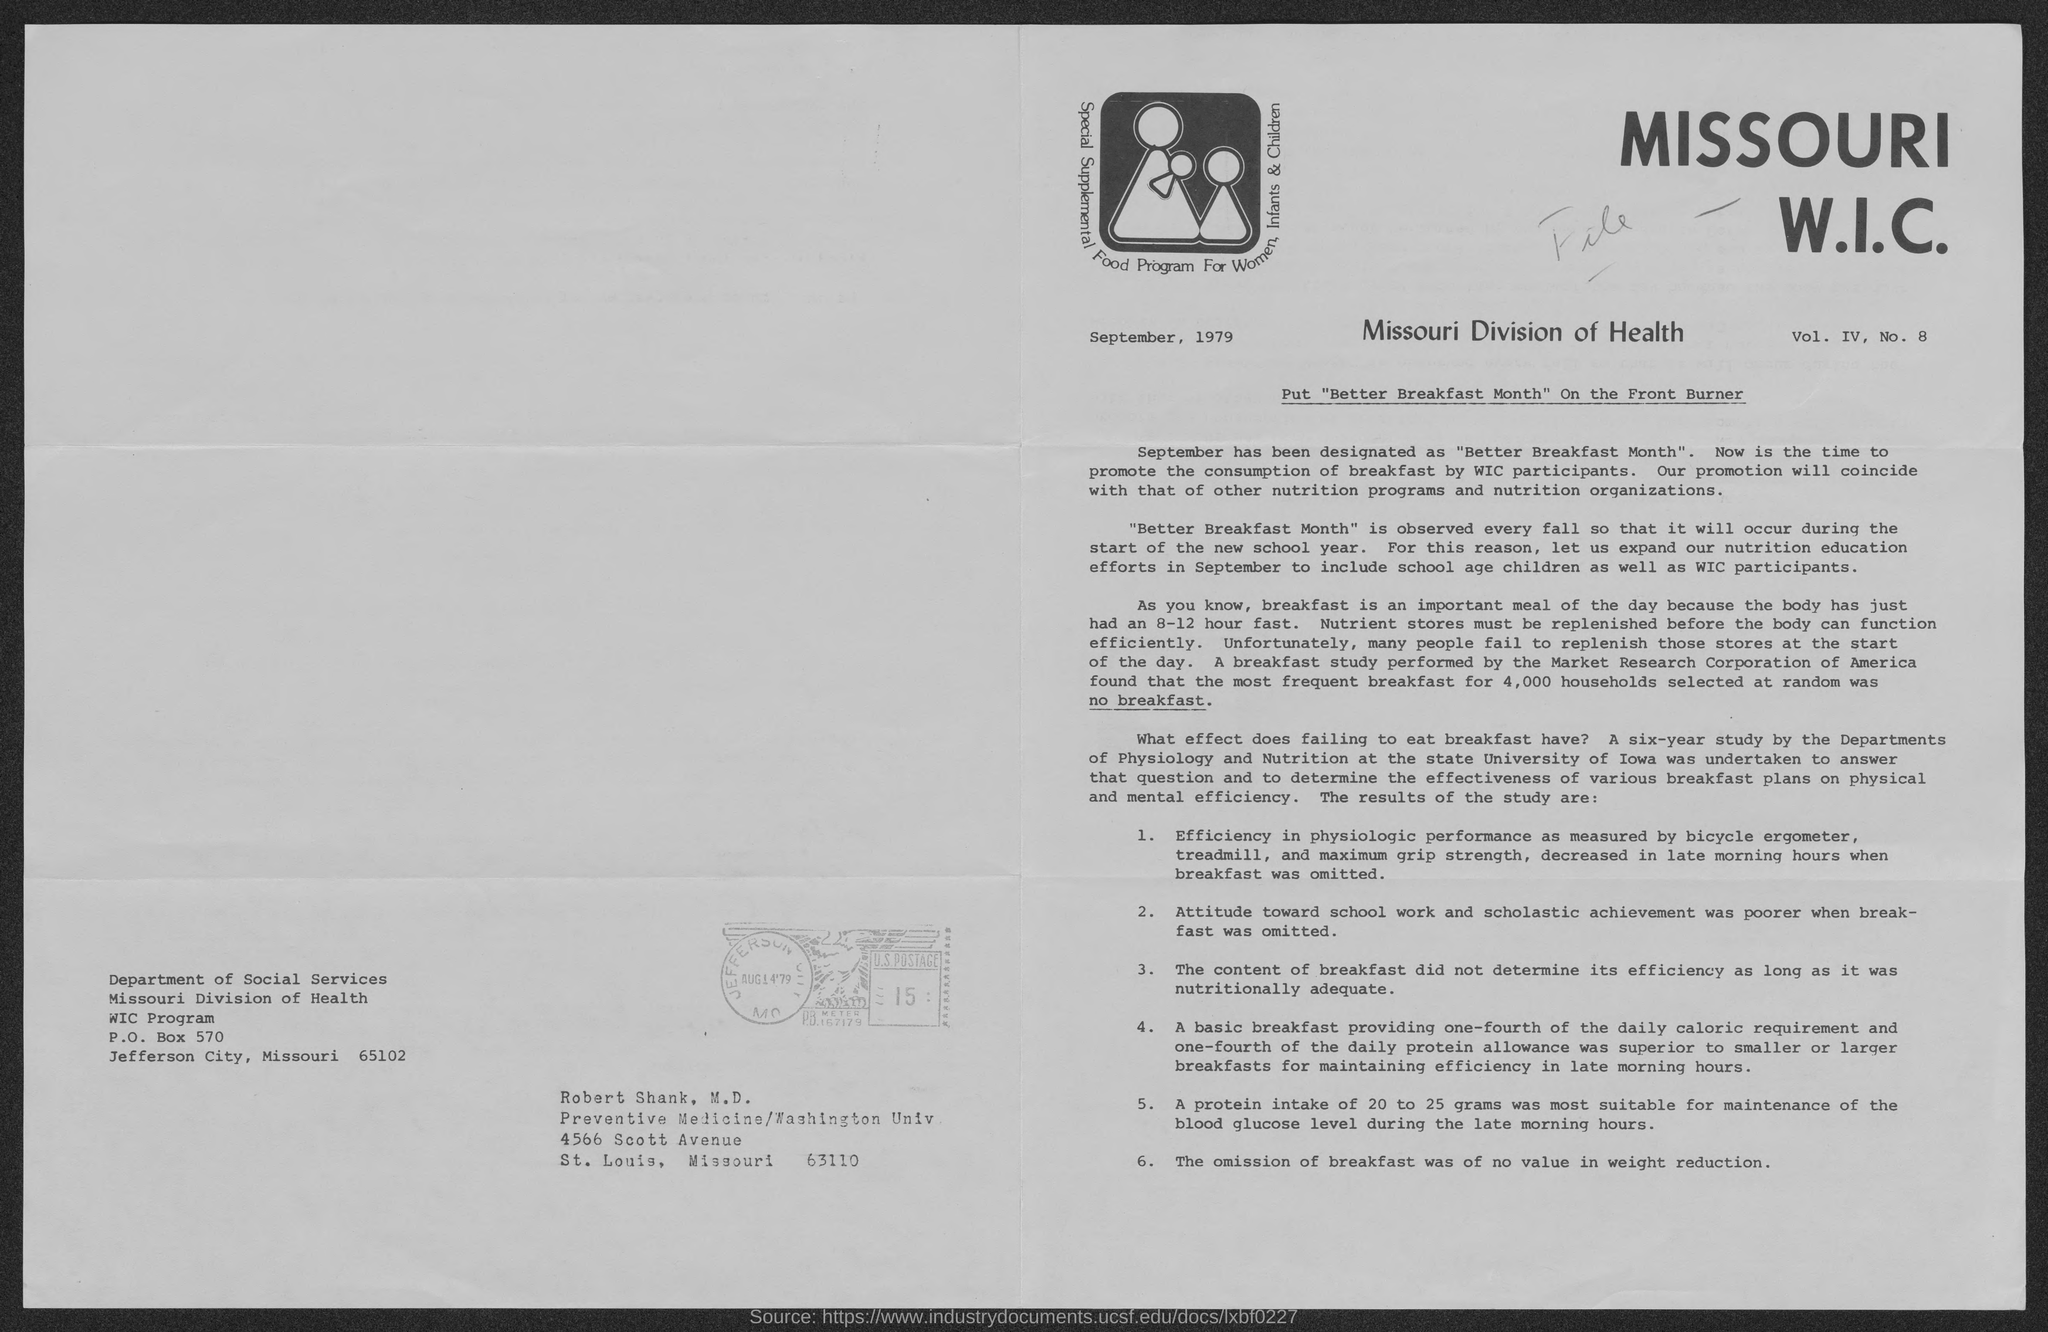List a handful of essential elements in this visual. The Missouri Division of Health is located in the state of Missouri. The P.O. box number of the Missouri Division of Health is 570, and it is located in P.O. boxes. The Zipcode of the Missouri Division of Health is 65102. Preventive medicine, which is located at Washington University in the state of Missouri. 